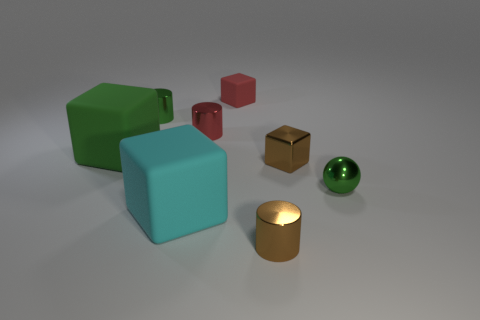Add 1 tiny green rubber balls. How many objects exist? 9 Subtract all cylinders. How many objects are left? 5 Add 3 big green cubes. How many big green cubes are left? 4 Add 8 large gray balls. How many large gray balls exist? 8 Subtract 0 red spheres. How many objects are left? 8 Subtract all red matte objects. Subtract all large green shiny blocks. How many objects are left? 7 